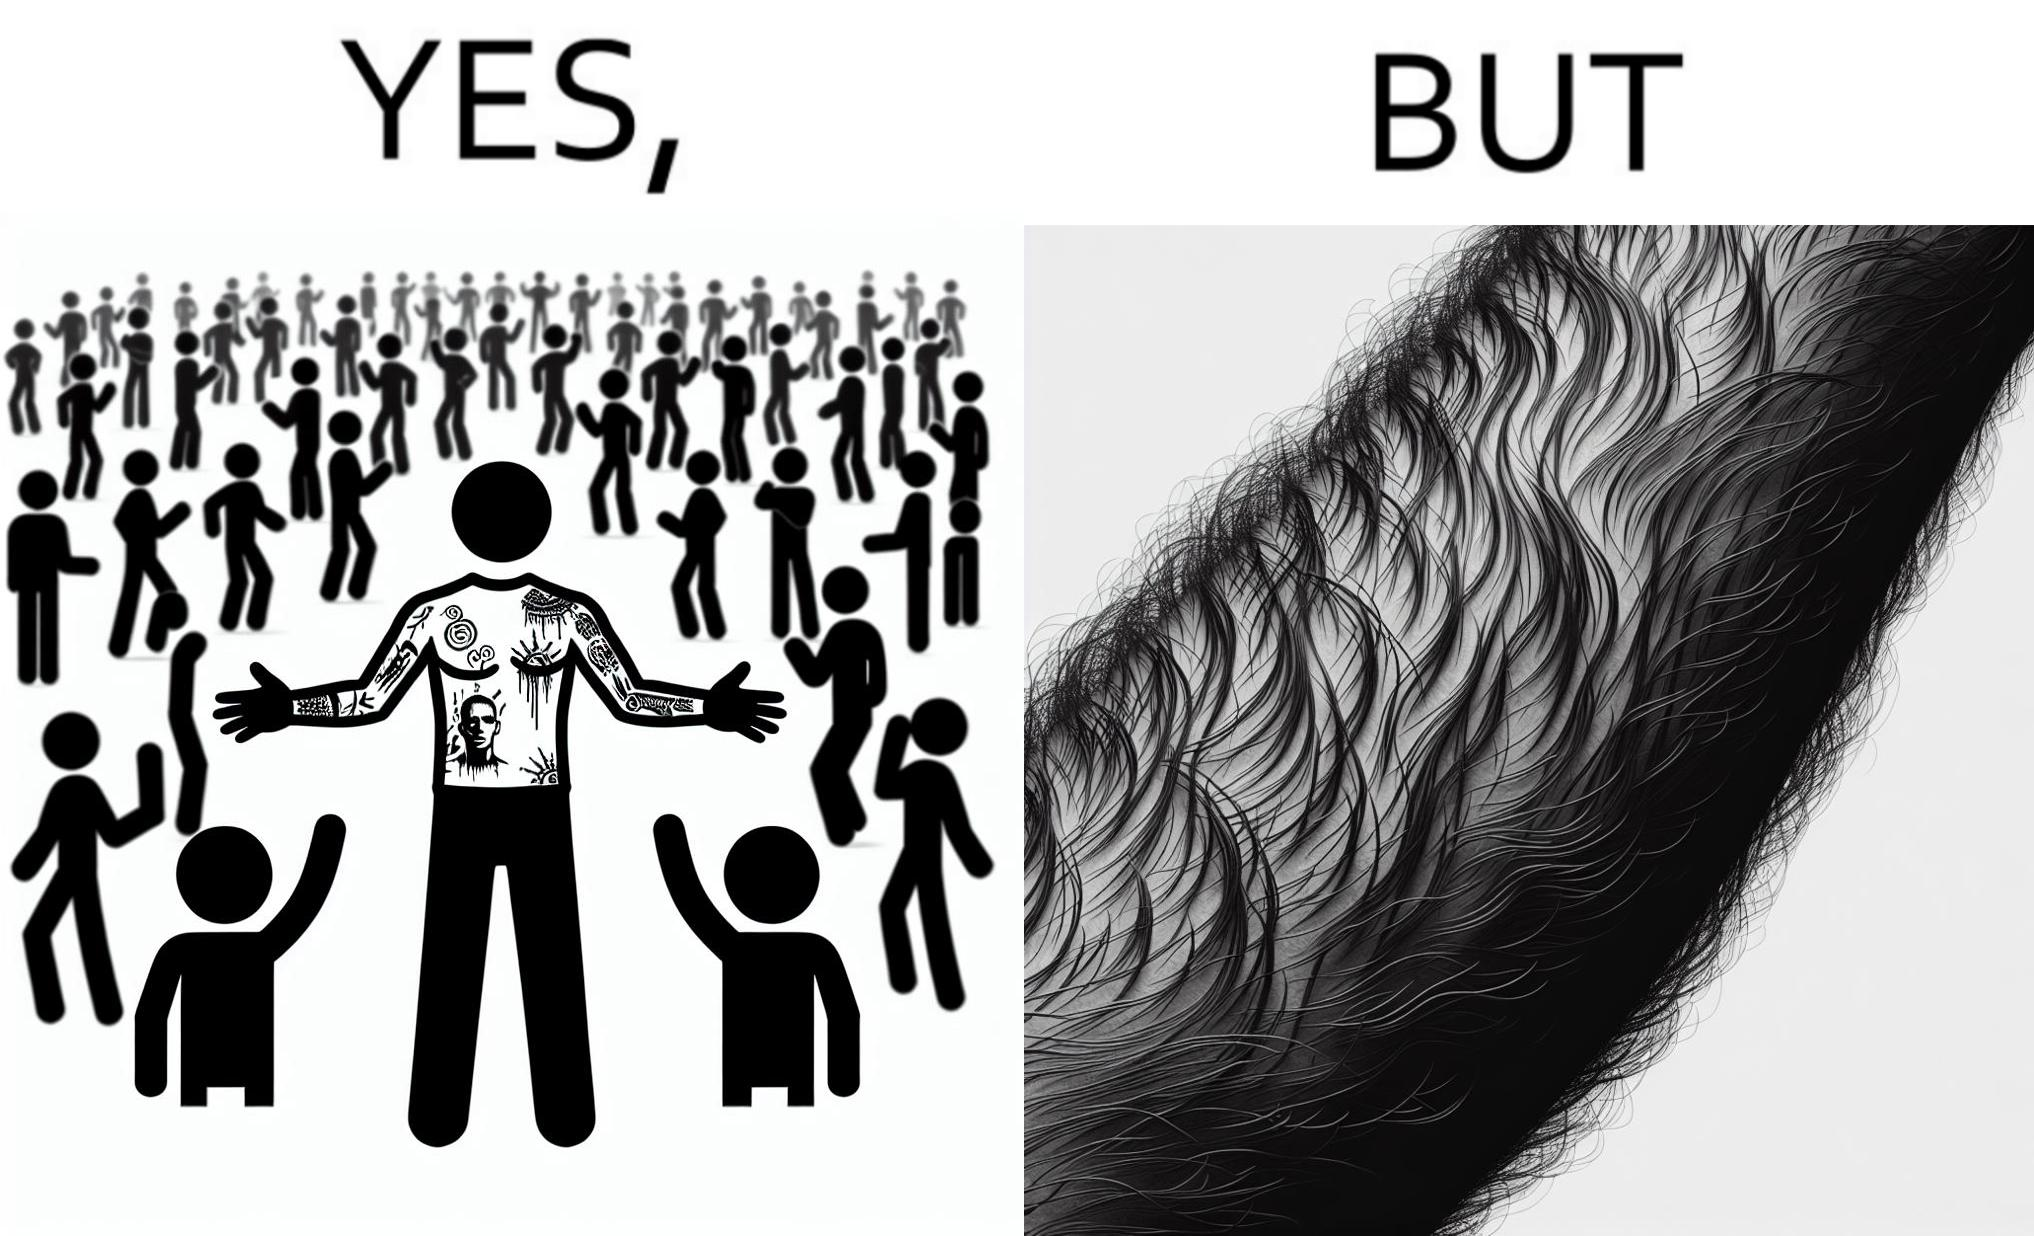Does this image contain satire or humor? Yes, this image is satirical. 